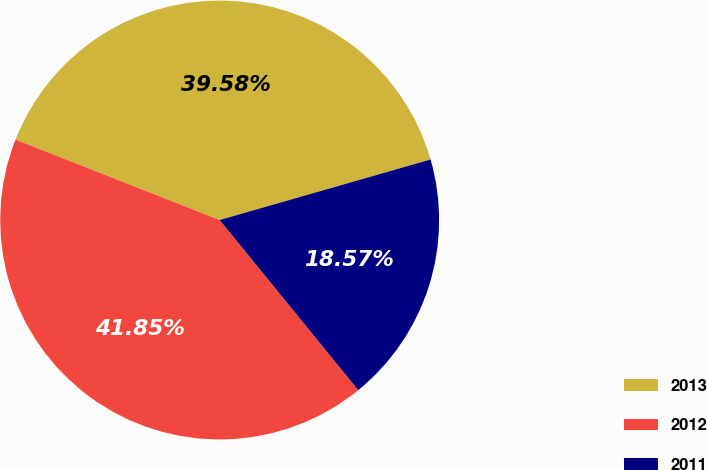<chart> <loc_0><loc_0><loc_500><loc_500><pie_chart><fcel>2013<fcel>2012<fcel>2011<nl><fcel>39.58%<fcel>41.85%<fcel>18.57%<nl></chart> 